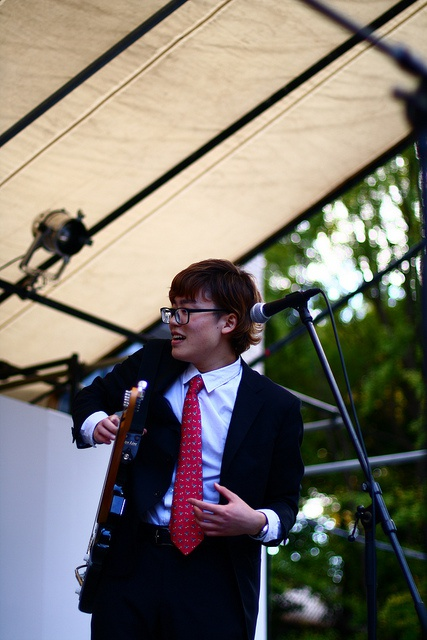Describe the objects in this image and their specific colors. I can see people in gray, black, maroon, purple, and lightblue tones, tie in gray, brown, maroon, and purple tones, and clock in gray, black, navy, white, and violet tones in this image. 